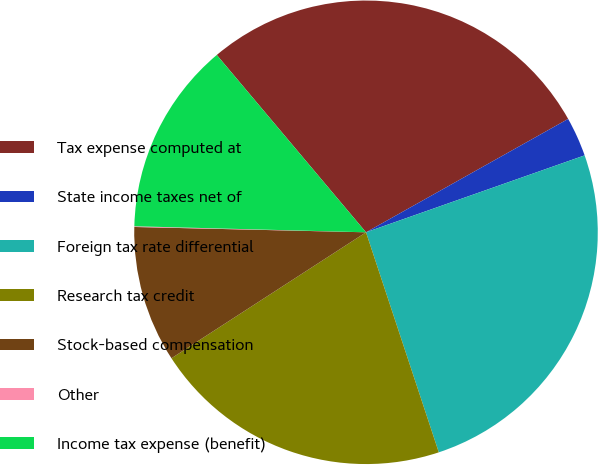<chart> <loc_0><loc_0><loc_500><loc_500><pie_chart><fcel>Tax expense computed at<fcel>State income taxes net of<fcel>Foreign tax rate differential<fcel>Research tax credit<fcel>Stock-based compensation<fcel>Other<fcel>Income tax expense (benefit)<nl><fcel>28.0%<fcel>2.75%<fcel>25.3%<fcel>20.94%<fcel>9.51%<fcel>0.05%<fcel>13.45%<nl></chart> 